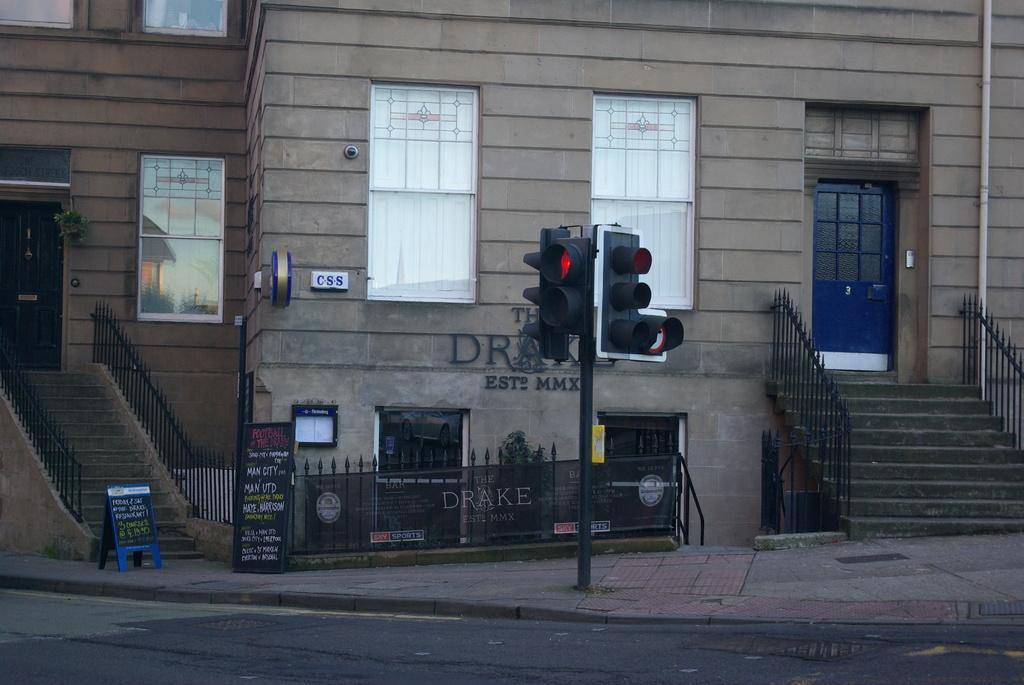How would you summarize this image in a sentence or two? In this picture I can see there is a traffic light signal attached to the pole and in the backdrop there is a building. 